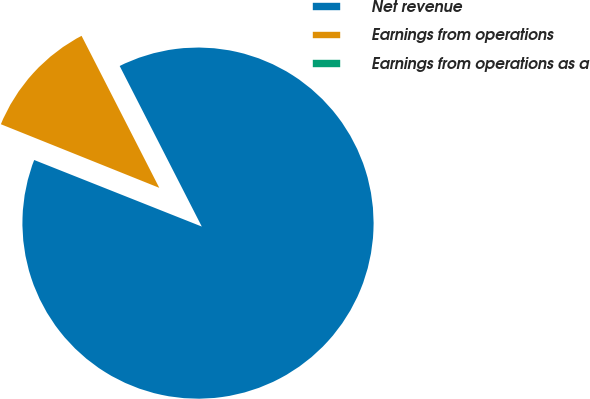Convert chart. <chart><loc_0><loc_0><loc_500><loc_500><pie_chart><fcel>Net revenue<fcel>Earnings from operations<fcel>Earnings from operations as a<nl><fcel>88.54%<fcel>11.4%<fcel>0.06%<nl></chart> 